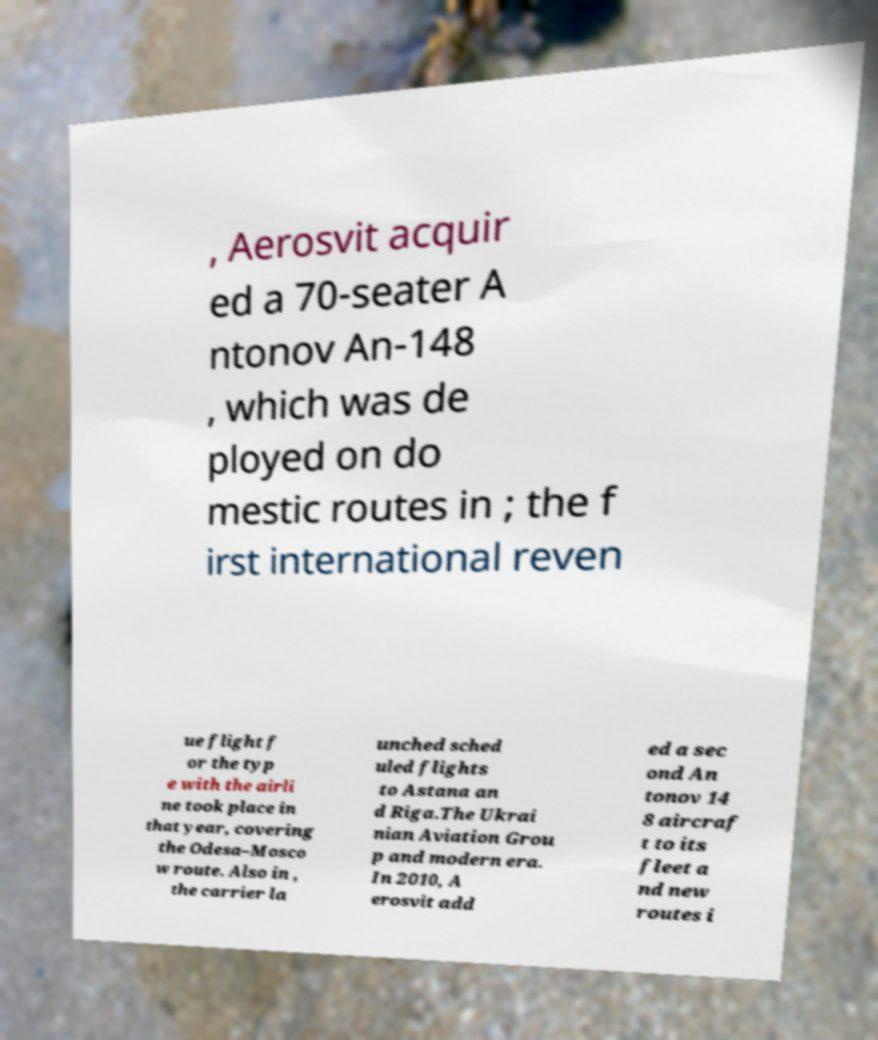Please identify and transcribe the text found in this image. , Aerosvit acquir ed a 70-seater A ntonov An-148 , which was de ployed on do mestic routes in ; the f irst international reven ue flight f or the typ e with the airli ne took place in that year, covering the Odesa–Mosco w route. Also in , the carrier la unched sched uled flights to Astana an d Riga.The Ukrai nian Aviation Grou p and modern era. In 2010, A erosvit add ed a sec ond An tonov 14 8 aircraf t to its fleet a nd new routes i 